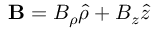Convert formula to latex. <formula><loc_0><loc_0><loc_500><loc_500>B = B _ { \rho } \hat { \rho } + B _ { z } \hat { z }</formula> 